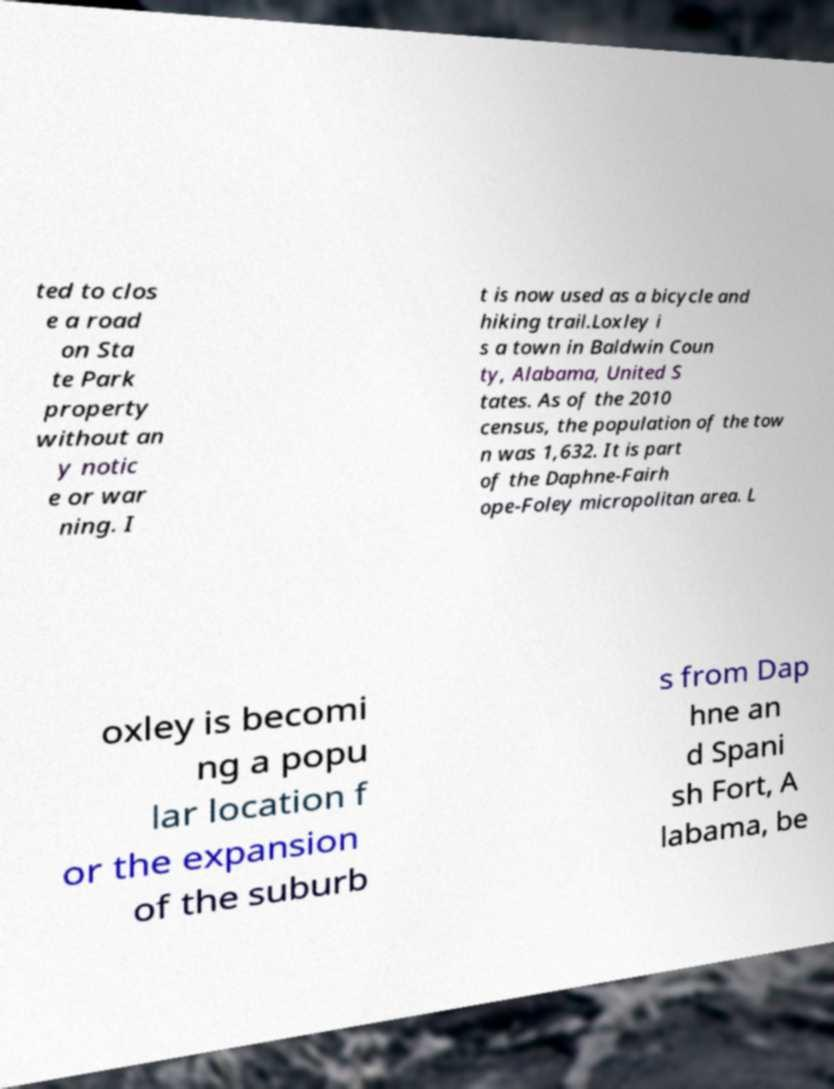Please read and relay the text visible in this image. What does it say? ted to clos e a road on Sta te Park property without an y notic e or war ning. I t is now used as a bicycle and hiking trail.Loxley i s a town in Baldwin Coun ty, Alabama, United S tates. As of the 2010 census, the population of the tow n was 1,632. It is part of the Daphne-Fairh ope-Foley micropolitan area. L oxley is becomi ng a popu lar location f or the expansion of the suburb s from Dap hne an d Spani sh Fort, A labama, be 